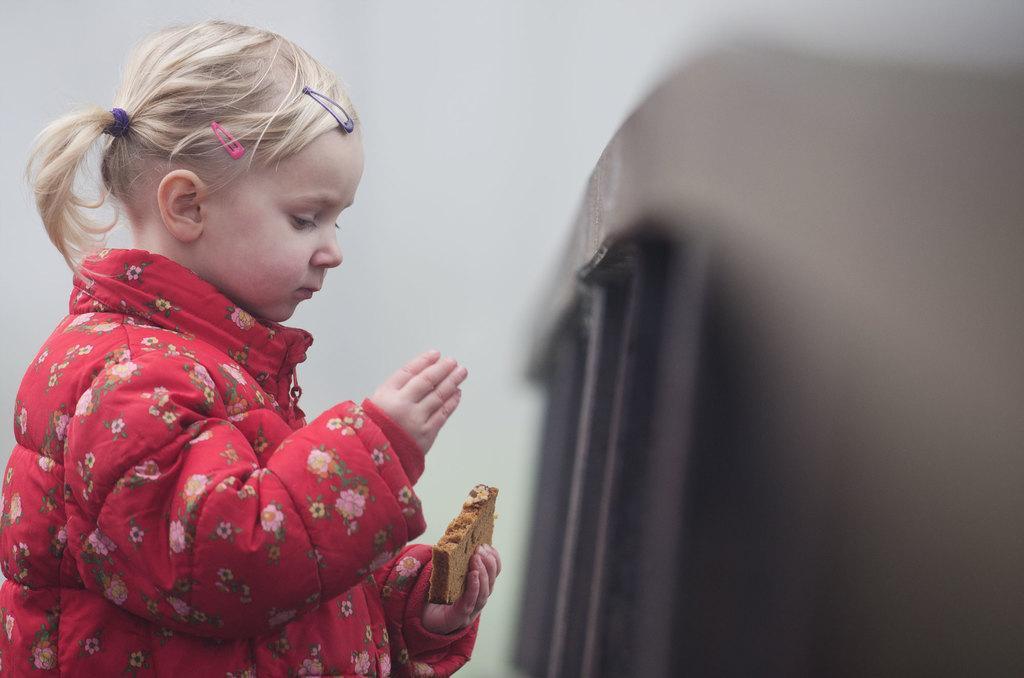Can you describe this image briefly? In this image we can see a child holding a piece of bread. On the right side we can see a barricade. 